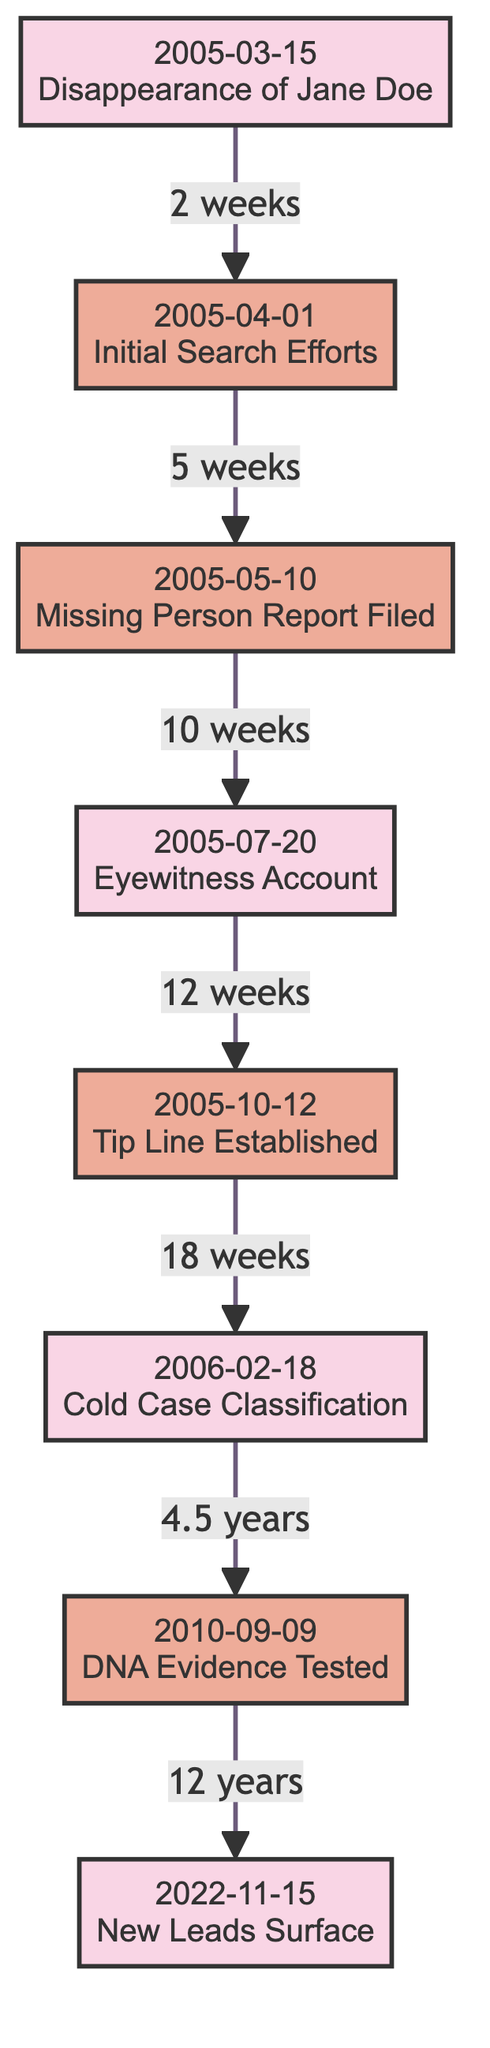What is the first event in the timeline? The first event in the timeline is the disappearance of Jane Doe, which is indicated by the earliest node labeled with the date and action.
Answer: Disappearance of Jane Doe How many total events are presented in the diagram? By counting the nodes listed in the diagram, there are eight events displayed, each corresponding to a significant date and action.
Answer: 8 Which action took place five weeks after the initial search efforts? By tracing the timeline, "Missing Person Report Filed" occurs five weeks after "Initial Search Efforts" as indicated by the connection between those two nodes.
Answer: Missing Person Report Filed What is the time gap between "Cold Case Classification" and "DNA Evidence Tested"? The connection shows that 4.5 years separate these two events, occurring after the cold case was classified and the DNA evidence was tested subsequently.
Answer: 4.5 years What is the last action taken in the timeline? The last action listed in the timeline is "New Leads Surface," which is the most recent event, indicated by the last node in the diagram.
Answer: New Leads Surface How many weeks are there between "Eyewitness Account" and "Tip Line Established"? The connection between these two nodes indicates that there are 12 weeks between "Eyewitness Account" and "Tip Line Established."
Answer: 12 weeks What significant classification occurred on February 18, 2006? The diagram indicates that on this date, Jane's case was officially classified as a cold case, which is a key milestone in the investigation timeline.
Answer: Cold Case Classification What action follows the establishment of the tip line? Following the establishment of the tip line, the case was classified as a cold case, which shows a progression in the events depicted in the timeline.
Answer: Cold Case Classification 